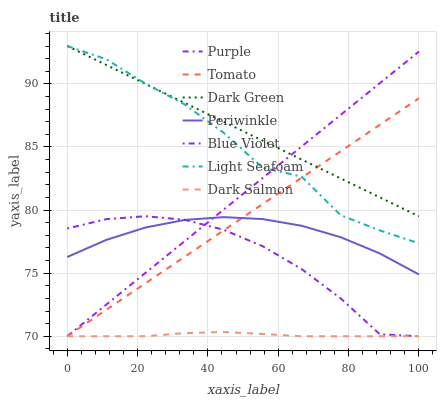Does Dark Salmon have the minimum area under the curve?
Answer yes or no. Yes. Does Dark Green have the maximum area under the curve?
Answer yes or no. Yes. Does Purple have the minimum area under the curve?
Answer yes or no. No. Does Purple have the maximum area under the curve?
Answer yes or no. No. Is Dark Green the smoothest?
Answer yes or no. Yes. Is Light Seafoam the roughest?
Answer yes or no. Yes. Is Purple the smoothest?
Answer yes or no. No. Is Purple the roughest?
Answer yes or no. No. Does Tomato have the lowest value?
Answer yes or no. Yes. Does Periwinkle have the lowest value?
Answer yes or no. No. Does Dark Green have the highest value?
Answer yes or no. Yes. Does Purple have the highest value?
Answer yes or no. No. Is Blue Violet less than Dark Green?
Answer yes or no. Yes. Is Dark Green greater than Periwinkle?
Answer yes or no. Yes. Does Dark Green intersect Tomato?
Answer yes or no. Yes. Is Dark Green less than Tomato?
Answer yes or no. No. Is Dark Green greater than Tomato?
Answer yes or no. No. Does Blue Violet intersect Dark Green?
Answer yes or no. No. 